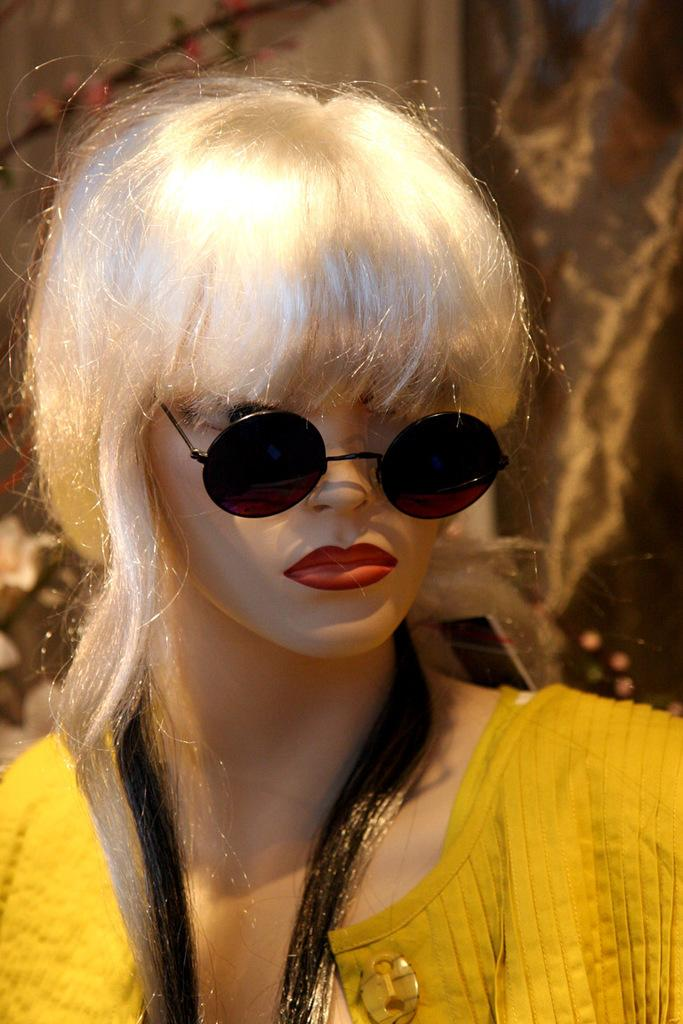What is the main subject in the middle of the image? There is a doll in the middle of the image. What is the doll wearing? The doll is wearing a dress and goggles. What type of blade can be seen cutting through the water in the image? There is no blade or water present in the image; it features a doll wearing a dress and goggles. How many boats are visible in the image? There are no boats present in the image. 